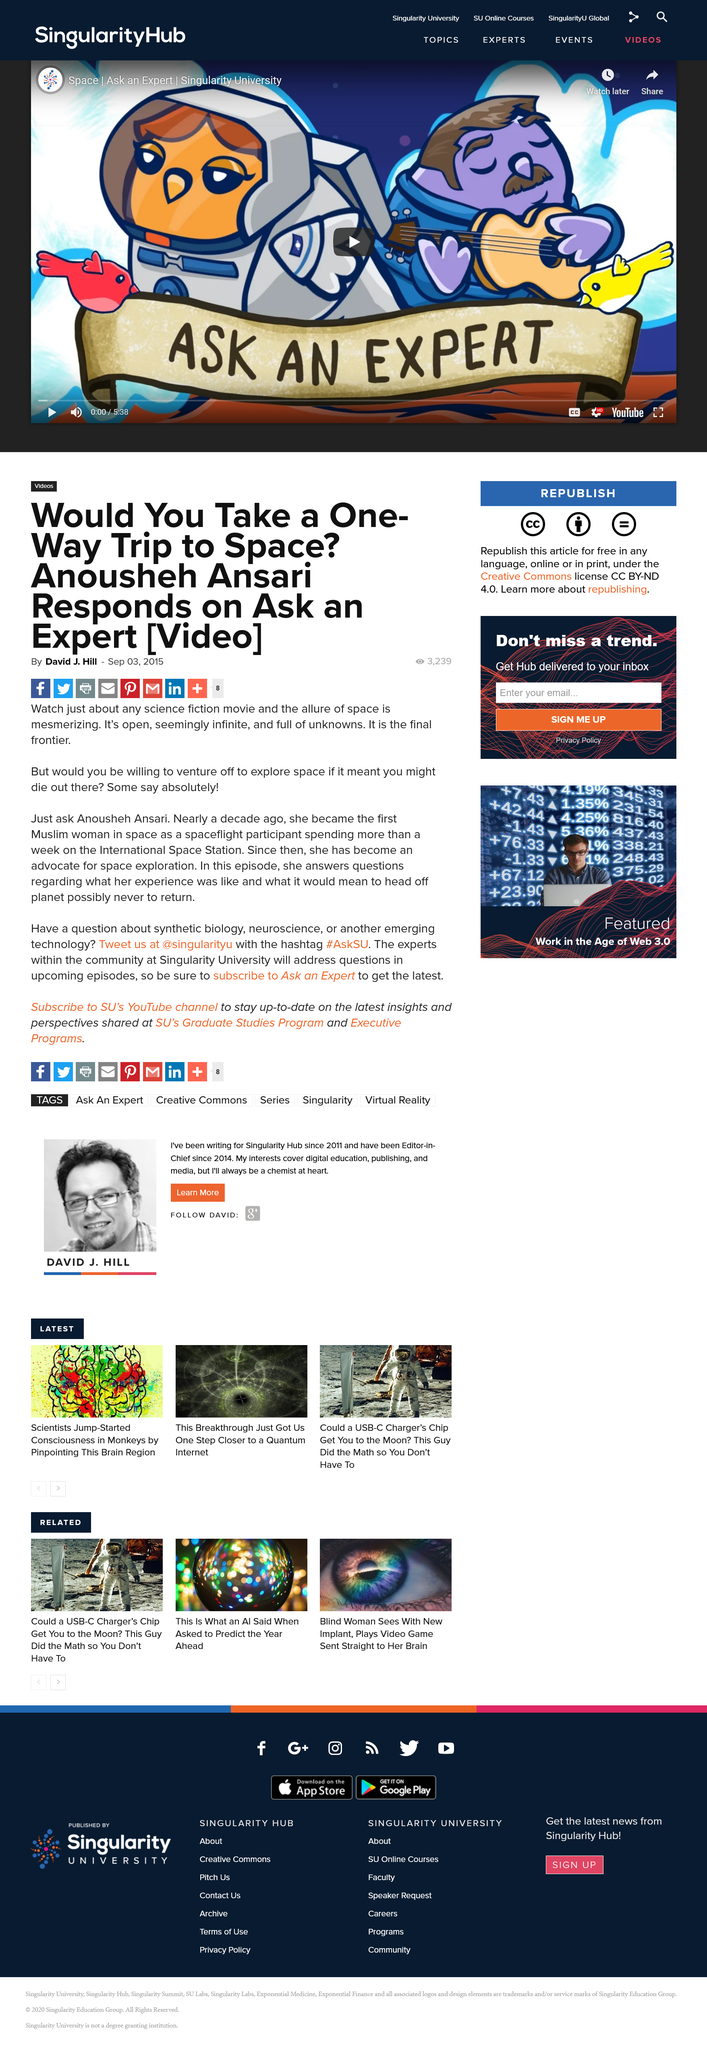Draw attention to some important aspects in this diagram. Anousheh Ansari was the first Muslim woman to go into space as a spaceflight participant. The article titled "Would You Take a One-Way Trip to Space?" was written by David J. Hill. Anousheh Ansari became an advocate for space exploration after her historic journey to the International Space Station. 